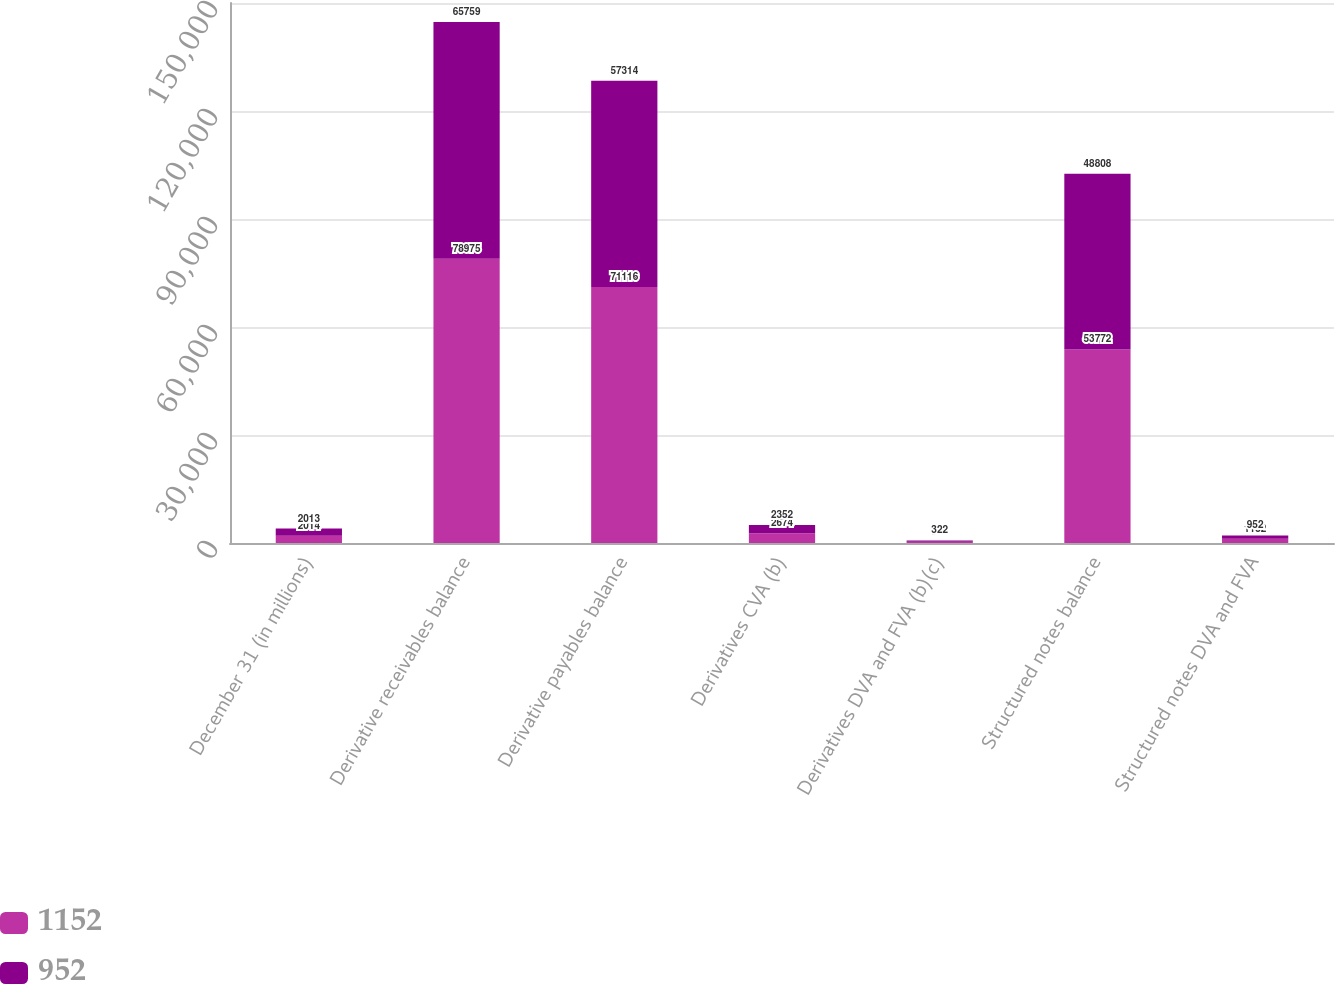Convert chart. <chart><loc_0><loc_0><loc_500><loc_500><stacked_bar_chart><ecel><fcel>December 31 (in millions)<fcel>Derivative receivables balance<fcel>Derivative payables balance<fcel>Derivatives CVA (b)<fcel>Derivatives DVA and FVA (b)(c)<fcel>Structured notes balance<fcel>Structured notes DVA and FVA<nl><fcel>1152<fcel>2014<fcel>78975<fcel>71116<fcel>2674<fcel>380<fcel>53772<fcel>1152<nl><fcel>952<fcel>2013<fcel>65759<fcel>57314<fcel>2352<fcel>322<fcel>48808<fcel>952<nl></chart> 